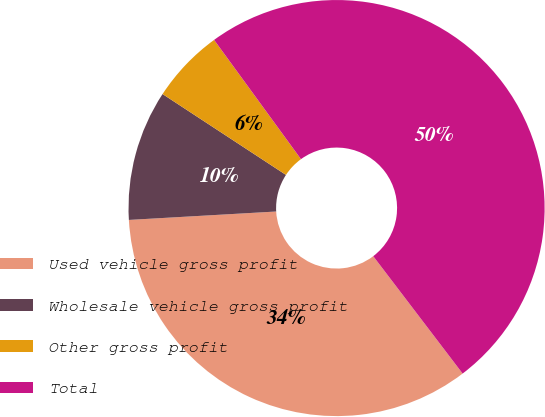Convert chart. <chart><loc_0><loc_0><loc_500><loc_500><pie_chart><fcel>Used vehicle gross profit<fcel>Wholesale vehicle gross profit<fcel>Other gross profit<fcel>Total<nl><fcel>34.45%<fcel>10.14%<fcel>5.75%<fcel>49.66%<nl></chart> 